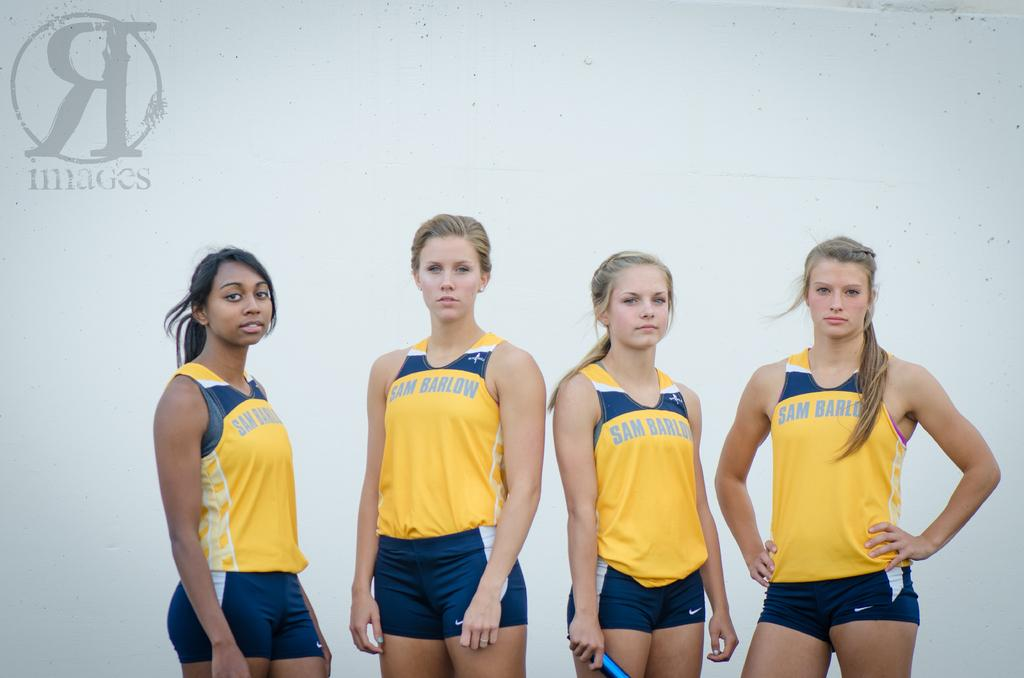<image>
Share a concise interpretation of the image provided. Four girls wearing uniforms reading Sam Barlow are standing side by side. 